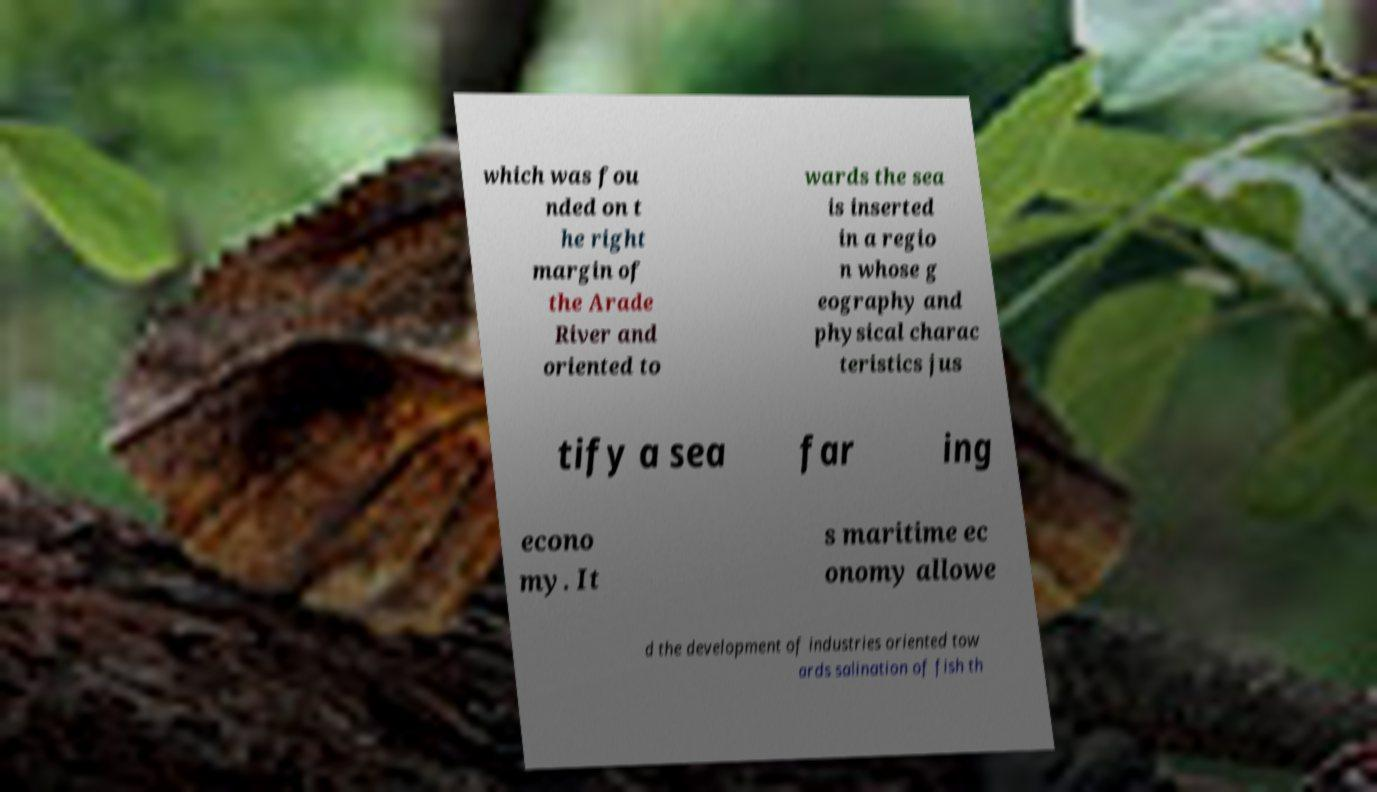Can you accurately transcribe the text from the provided image for me? which was fou nded on t he right margin of the Arade River and oriented to wards the sea is inserted in a regio n whose g eography and physical charac teristics jus tify a sea far ing econo my. It s maritime ec onomy allowe d the development of industries oriented tow ards salination of fish th 